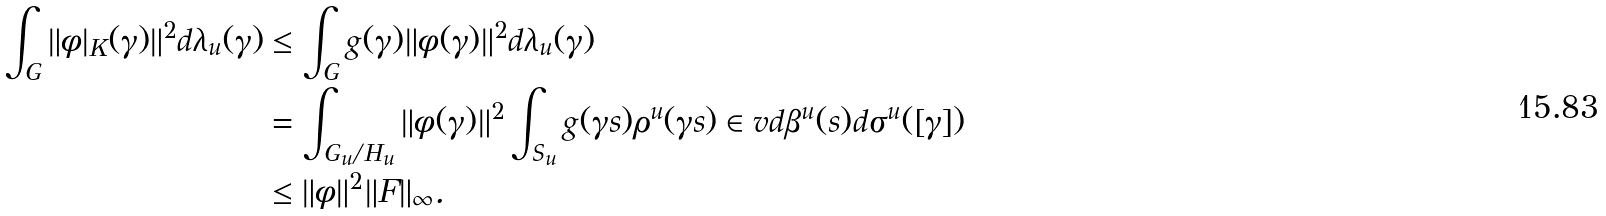<formula> <loc_0><loc_0><loc_500><loc_500>\int _ { G } \| \phi | _ { K } ( \gamma ) \| ^ { 2 } d \lambda _ { u } ( \gamma ) & \leq \int _ { G } g ( \gamma ) \| \phi ( \gamma ) \| ^ { 2 } d \lambda _ { u } ( \gamma ) \\ & = \int _ { G _ { u } / H _ { u } } \| \phi ( \gamma ) \| ^ { 2 } \int _ { S _ { u } } g ( \gamma s ) \rho ^ { u } ( \gamma s ) \in v d \beta ^ { u } ( s ) d \sigma ^ { u } ( [ \gamma ] ) \\ & \leq \| \phi \| ^ { 2 } \| F \| _ { \infty } .</formula> 